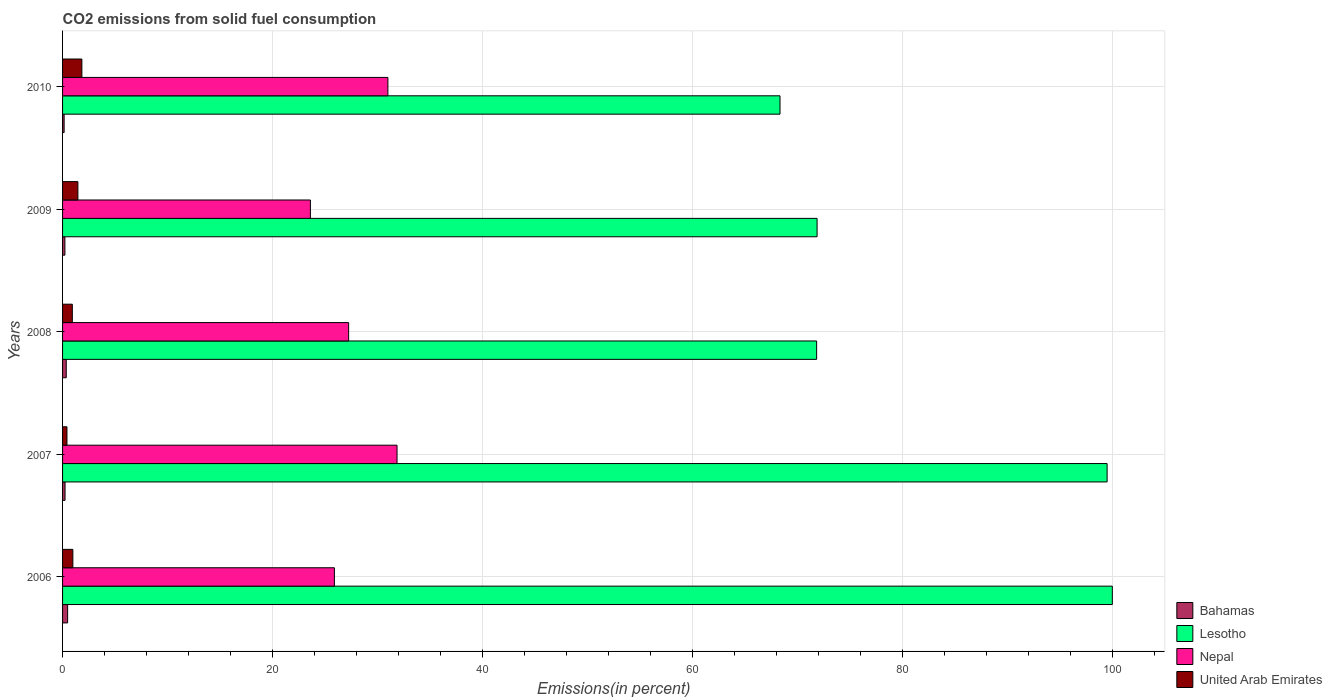How many bars are there on the 2nd tick from the bottom?
Offer a terse response. 4. What is the total CO2 emitted in Lesotho in 2009?
Your answer should be compact. 71.88. Across all years, what is the maximum total CO2 emitted in Nepal?
Provide a short and direct response. 31.86. Across all years, what is the minimum total CO2 emitted in Nepal?
Provide a short and direct response. 23.61. In which year was the total CO2 emitted in Lesotho maximum?
Your answer should be very brief. 2006. What is the total total CO2 emitted in Lesotho in the graph?
Your answer should be compact. 411.55. What is the difference between the total CO2 emitted in Nepal in 2007 and that in 2009?
Ensure brevity in your answer.  8.25. What is the difference between the total CO2 emitted in Nepal in 2009 and the total CO2 emitted in United Arab Emirates in 2008?
Offer a very short reply. 22.68. What is the average total CO2 emitted in United Arab Emirates per year?
Provide a succinct answer. 1.13. In the year 2009, what is the difference between the total CO2 emitted in United Arab Emirates and total CO2 emitted in Lesotho?
Make the answer very short. -70.42. In how many years, is the total CO2 emitted in United Arab Emirates greater than 84 %?
Make the answer very short. 0. What is the ratio of the total CO2 emitted in United Arab Emirates in 2007 to that in 2009?
Ensure brevity in your answer.  0.29. Is the total CO2 emitted in Lesotho in 2007 less than that in 2008?
Make the answer very short. No. Is the difference between the total CO2 emitted in United Arab Emirates in 2007 and 2009 greater than the difference between the total CO2 emitted in Lesotho in 2007 and 2009?
Your answer should be very brief. No. What is the difference between the highest and the second highest total CO2 emitted in United Arab Emirates?
Make the answer very short. 0.38. What is the difference between the highest and the lowest total CO2 emitted in Nepal?
Provide a short and direct response. 8.25. Is the sum of the total CO2 emitted in Nepal in 2006 and 2007 greater than the maximum total CO2 emitted in United Arab Emirates across all years?
Provide a short and direct response. Yes. Is it the case that in every year, the sum of the total CO2 emitted in Bahamas and total CO2 emitted in United Arab Emirates is greater than the sum of total CO2 emitted in Nepal and total CO2 emitted in Lesotho?
Offer a very short reply. No. What does the 1st bar from the top in 2006 represents?
Offer a terse response. United Arab Emirates. What does the 1st bar from the bottom in 2008 represents?
Your response must be concise. Bahamas. How many bars are there?
Provide a short and direct response. 20. Are all the bars in the graph horizontal?
Your response must be concise. Yes. How many years are there in the graph?
Provide a short and direct response. 5. What is the difference between two consecutive major ticks on the X-axis?
Provide a succinct answer. 20. Are the values on the major ticks of X-axis written in scientific E-notation?
Offer a very short reply. No. Does the graph contain grids?
Offer a terse response. Yes. How are the legend labels stacked?
Keep it short and to the point. Vertical. What is the title of the graph?
Give a very brief answer. CO2 emissions from solid fuel consumption. What is the label or title of the X-axis?
Your response must be concise. Emissions(in percent). What is the Emissions(in percent) of Bahamas in 2006?
Give a very brief answer. 0.48. What is the Emissions(in percent) in Nepal in 2006?
Your response must be concise. 25.9. What is the Emissions(in percent) in United Arab Emirates in 2006?
Provide a succinct answer. 0.98. What is the Emissions(in percent) in Bahamas in 2007?
Ensure brevity in your answer.  0.24. What is the Emissions(in percent) of Lesotho in 2007?
Offer a very short reply. 99.5. What is the Emissions(in percent) of Nepal in 2007?
Your response must be concise. 31.86. What is the Emissions(in percent) in United Arab Emirates in 2007?
Keep it short and to the point. 0.42. What is the Emissions(in percent) of Bahamas in 2008?
Your response must be concise. 0.35. What is the Emissions(in percent) in Lesotho in 2008?
Provide a succinct answer. 71.83. What is the Emissions(in percent) in Nepal in 2008?
Your answer should be compact. 27.25. What is the Emissions(in percent) of United Arab Emirates in 2008?
Your response must be concise. 0.93. What is the Emissions(in percent) of Bahamas in 2009?
Make the answer very short. 0.22. What is the Emissions(in percent) of Lesotho in 2009?
Offer a terse response. 71.88. What is the Emissions(in percent) in Nepal in 2009?
Provide a succinct answer. 23.61. What is the Emissions(in percent) in United Arab Emirates in 2009?
Your response must be concise. 1.46. What is the Emissions(in percent) in Bahamas in 2010?
Your answer should be very brief. 0.15. What is the Emissions(in percent) in Lesotho in 2010?
Your answer should be compact. 68.34. What is the Emissions(in percent) in Nepal in 2010?
Your answer should be compact. 30.99. What is the Emissions(in percent) in United Arab Emirates in 2010?
Ensure brevity in your answer.  1.84. Across all years, what is the maximum Emissions(in percent) of Bahamas?
Provide a succinct answer. 0.48. Across all years, what is the maximum Emissions(in percent) of Nepal?
Your answer should be very brief. 31.86. Across all years, what is the maximum Emissions(in percent) in United Arab Emirates?
Provide a short and direct response. 1.84. Across all years, what is the minimum Emissions(in percent) of Bahamas?
Your answer should be very brief. 0.15. Across all years, what is the minimum Emissions(in percent) of Lesotho?
Ensure brevity in your answer.  68.34. Across all years, what is the minimum Emissions(in percent) of Nepal?
Your response must be concise. 23.61. Across all years, what is the minimum Emissions(in percent) of United Arab Emirates?
Offer a terse response. 0.42. What is the total Emissions(in percent) in Bahamas in the graph?
Make the answer very short. 1.44. What is the total Emissions(in percent) of Lesotho in the graph?
Give a very brief answer. 411.55. What is the total Emissions(in percent) in Nepal in the graph?
Give a very brief answer. 139.6. What is the total Emissions(in percent) of United Arab Emirates in the graph?
Your response must be concise. 5.63. What is the difference between the Emissions(in percent) in Bahamas in 2006 and that in 2007?
Ensure brevity in your answer.  0.24. What is the difference between the Emissions(in percent) in Lesotho in 2006 and that in 2007?
Give a very brief answer. 0.5. What is the difference between the Emissions(in percent) of Nepal in 2006 and that in 2007?
Provide a short and direct response. -5.97. What is the difference between the Emissions(in percent) of United Arab Emirates in 2006 and that in 2007?
Ensure brevity in your answer.  0.56. What is the difference between the Emissions(in percent) in Bahamas in 2006 and that in 2008?
Your answer should be very brief. 0.13. What is the difference between the Emissions(in percent) of Lesotho in 2006 and that in 2008?
Your response must be concise. 28.17. What is the difference between the Emissions(in percent) of Nepal in 2006 and that in 2008?
Offer a terse response. -1.36. What is the difference between the Emissions(in percent) of United Arab Emirates in 2006 and that in 2008?
Offer a terse response. 0.05. What is the difference between the Emissions(in percent) in Bahamas in 2006 and that in 2009?
Provide a short and direct response. 0.26. What is the difference between the Emissions(in percent) in Lesotho in 2006 and that in 2009?
Offer a very short reply. 28.12. What is the difference between the Emissions(in percent) of Nepal in 2006 and that in 2009?
Provide a short and direct response. 2.29. What is the difference between the Emissions(in percent) in United Arab Emirates in 2006 and that in 2009?
Offer a very short reply. -0.48. What is the difference between the Emissions(in percent) in Bahamas in 2006 and that in 2010?
Offer a very short reply. 0.33. What is the difference between the Emissions(in percent) of Lesotho in 2006 and that in 2010?
Offer a very short reply. 31.66. What is the difference between the Emissions(in percent) in Nepal in 2006 and that in 2010?
Offer a terse response. -5.1. What is the difference between the Emissions(in percent) in United Arab Emirates in 2006 and that in 2010?
Provide a short and direct response. -0.86. What is the difference between the Emissions(in percent) in Bahamas in 2007 and that in 2008?
Offer a very short reply. -0.11. What is the difference between the Emissions(in percent) in Lesotho in 2007 and that in 2008?
Provide a succinct answer. 27.67. What is the difference between the Emissions(in percent) of Nepal in 2007 and that in 2008?
Your response must be concise. 4.61. What is the difference between the Emissions(in percent) of United Arab Emirates in 2007 and that in 2008?
Offer a very short reply. -0.51. What is the difference between the Emissions(in percent) of Bahamas in 2007 and that in 2009?
Ensure brevity in your answer.  0.01. What is the difference between the Emissions(in percent) in Lesotho in 2007 and that in 2009?
Ensure brevity in your answer.  27.63. What is the difference between the Emissions(in percent) of Nepal in 2007 and that in 2009?
Offer a terse response. 8.25. What is the difference between the Emissions(in percent) of United Arab Emirates in 2007 and that in 2009?
Keep it short and to the point. -1.04. What is the difference between the Emissions(in percent) of Bahamas in 2007 and that in 2010?
Provide a succinct answer. 0.09. What is the difference between the Emissions(in percent) of Lesotho in 2007 and that in 2010?
Your answer should be very brief. 31.16. What is the difference between the Emissions(in percent) of Nepal in 2007 and that in 2010?
Make the answer very short. 0.87. What is the difference between the Emissions(in percent) in United Arab Emirates in 2007 and that in 2010?
Make the answer very short. -1.42. What is the difference between the Emissions(in percent) in Bahamas in 2008 and that in 2009?
Your response must be concise. 0.13. What is the difference between the Emissions(in percent) of Lesotho in 2008 and that in 2009?
Your answer should be compact. -0.04. What is the difference between the Emissions(in percent) in Nepal in 2008 and that in 2009?
Give a very brief answer. 3.64. What is the difference between the Emissions(in percent) of United Arab Emirates in 2008 and that in 2009?
Provide a short and direct response. -0.53. What is the difference between the Emissions(in percent) of Bahamas in 2008 and that in 2010?
Your response must be concise. 0.2. What is the difference between the Emissions(in percent) of Lesotho in 2008 and that in 2010?
Your answer should be very brief. 3.49. What is the difference between the Emissions(in percent) of Nepal in 2008 and that in 2010?
Offer a terse response. -3.74. What is the difference between the Emissions(in percent) in United Arab Emirates in 2008 and that in 2010?
Offer a very short reply. -0.91. What is the difference between the Emissions(in percent) in Bahamas in 2009 and that in 2010?
Offer a terse response. 0.07. What is the difference between the Emissions(in percent) in Lesotho in 2009 and that in 2010?
Your answer should be very brief. 3.53. What is the difference between the Emissions(in percent) in Nepal in 2009 and that in 2010?
Offer a very short reply. -7.38. What is the difference between the Emissions(in percent) in United Arab Emirates in 2009 and that in 2010?
Offer a terse response. -0.38. What is the difference between the Emissions(in percent) in Bahamas in 2006 and the Emissions(in percent) in Lesotho in 2007?
Give a very brief answer. -99.02. What is the difference between the Emissions(in percent) in Bahamas in 2006 and the Emissions(in percent) in Nepal in 2007?
Keep it short and to the point. -31.38. What is the difference between the Emissions(in percent) of Bahamas in 2006 and the Emissions(in percent) of United Arab Emirates in 2007?
Give a very brief answer. 0.06. What is the difference between the Emissions(in percent) in Lesotho in 2006 and the Emissions(in percent) in Nepal in 2007?
Your response must be concise. 68.14. What is the difference between the Emissions(in percent) of Lesotho in 2006 and the Emissions(in percent) of United Arab Emirates in 2007?
Your answer should be very brief. 99.58. What is the difference between the Emissions(in percent) in Nepal in 2006 and the Emissions(in percent) in United Arab Emirates in 2007?
Provide a short and direct response. 25.48. What is the difference between the Emissions(in percent) of Bahamas in 2006 and the Emissions(in percent) of Lesotho in 2008?
Make the answer very short. -71.35. What is the difference between the Emissions(in percent) in Bahamas in 2006 and the Emissions(in percent) in Nepal in 2008?
Provide a short and direct response. -26.77. What is the difference between the Emissions(in percent) of Bahamas in 2006 and the Emissions(in percent) of United Arab Emirates in 2008?
Your answer should be very brief. -0.45. What is the difference between the Emissions(in percent) of Lesotho in 2006 and the Emissions(in percent) of Nepal in 2008?
Make the answer very short. 72.75. What is the difference between the Emissions(in percent) of Lesotho in 2006 and the Emissions(in percent) of United Arab Emirates in 2008?
Provide a succinct answer. 99.07. What is the difference between the Emissions(in percent) in Nepal in 2006 and the Emissions(in percent) in United Arab Emirates in 2008?
Offer a very short reply. 24.97. What is the difference between the Emissions(in percent) in Bahamas in 2006 and the Emissions(in percent) in Lesotho in 2009?
Make the answer very short. -71.39. What is the difference between the Emissions(in percent) in Bahamas in 2006 and the Emissions(in percent) in Nepal in 2009?
Keep it short and to the point. -23.12. What is the difference between the Emissions(in percent) of Bahamas in 2006 and the Emissions(in percent) of United Arab Emirates in 2009?
Your answer should be very brief. -0.98. What is the difference between the Emissions(in percent) of Lesotho in 2006 and the Emissions(in percent) of Nepal in 2009?
Ensure brevity in your answer.  76.39. What is the difference between the Emissions(in percent) in Lesotho in 2006 and the Emissions(in percent) in United Arab Emirates in 2009?
Offer a terse response. 98.54. What is the difference between the Emissions(in percent) in Nepal in 2006 and the Emissions(in percent) in United Arab Emirates in 2009?
Provide a short and direct response. 24.44. What is the difference between the Emissions(in percent) in Bahamas in 2006 and the Emissions(in percent) in Lesotho in 2010?
Provide a succinct answer. -67.86. What is the difference between the Emissions(in percent) of Bahamas in 2006 and the Emissions(in percent) of Nepal in 2010?
Offer a terse response. -30.51. What is the difference between the Emissions(in percent) in Bahamas in 2006 and the Emissions(in percent) in United Arab Emirates in 2010?
Offer a very short reply. -1.36. What is the difference between the Emissions(in percent) in Lesotho in 2006 and the Emissions(in percent) in Nepal in 2010?
Offer a terse response. 69.01. What is the difference between the Emissions(in percent) in Lesotho in 2006 and the Emissions(in percent) in United Arab Emirates in 2010?
Your answer should be very brief. 98.16. What is the difference between the Emissions(in percent) of Nepal in 2006 and the Emissions(in percent) of United Arab Emirates in 2010?
Your answer should be compact. 24.06. What is the difference between the Emissions(in percent) in Bahamas in 2007 and the Emissions(in percent) in Lesotho in 2008?
Keep it short and to the point. -71.59. What is the difference between the Emissions(in percent) in Bahamas in 2007 and the Emissions(in percent) in Nepal in 2008?
Keep it short and to the point. -27.01. What is the difference between the Emissions(in percent) in Bahamas in 2007 and the Emissions(in percent) in United Arab Emirates in 2008?
Offer a very short reply. -0.69. What is the difference between the Emissions(in percent) in Lesotho in 2007 and the Emissions(in percent) in Nepal in 2008?
Your answer should be compact. 72.25. What is the difference between the Emissions(in percent) of Lesotho in 2007 and the Emissions(in percent) of United Arab Emirates in 2008?
Offer a terse response. 98.57. What is the difference between the Emissions(in percent) of Nepal in 2007 and the Emissions(in percent) of United Arab Emirates in 2008?
Offer a terse response. 30.93. What is the difference between the Emissions(in percent) in Bahamas in 2007 and the Emissions(in percent) in Lesotho in 2009?
Your answer should be compact. -71.64. What is the difference between the Emissions(in percent) of Bahamas in 2007 and the Emissions(in percent) of Nepal in 2009?
Give a very brief answer. -23.37. What is the difference between the Emissions(in percent) of Bahamas in 2007 and the Emissions(in percent) of United Arab Emirates in 2009?
Your answer should be very brief. -1.22. What is the difference between the Emissions(in percent) of Lesotho in 2007 and the Emissions(in percent) of Nepal in 2009?
Provide a short and direct response. 75.9. What is the difference between the Emissions(in percent) of Lesotho in 2007 and the Emissions(in percent) of United Arab Emirates in 2009?
Your response must be concise. 98.04. What is the difference between the Emissions(in percent) of Nepal in 2007 and the Emissions(in percent) of United Arab Emirates in 2009?
Your answer should be compact. 30.4. What is the difference between the Emissions(in percent) of Bahamas in 2007 and the Emissions(in percent) of Lesotho in 2010?
Your answer should be compact. -68.11. What is the difference between the Emissions(in percent) of Bahamas in 2007 and the Emissions(in percent) of Nepal in 2010?
Your answer should be compact. -30.75. What is the difference between the Emissions(in percent) of Bahamas in 2007 and the Emissions(in percent) of United Arab Emirates in 2010?
Offer a terse response. -1.6. What is the difference between the Emissions(in percent) of Lesotho in 2007 and the Emissions(in percent) of Nepal in 2010?
Keep it short and to the point. 68.51. What is the difference between the Emissions(in percent) of Lesotho in 2007 and the Emissions(in percent) of United Arab Emirates in 2010?
Make the answer very short. 97.66. What is the difference between the Emissions(in percent) in Nepal in 2007 and the Emissions(in percent) in United Arab Emirates in 2010?
Your answer should be very brief. 30.02. What is the difference between the Emissions(in percent) of Bahamas in 2008 and the Emissions(in percent) of Lesotho in 2009?
Your answer should be very brief. -71.52. What is the difference between the Emissions(in percent) in Bahamas in 2008 and the Emissions(in percent) in Nepal in 2009?
Offer a very short reply. -23.26. What is the difference between the Emissions(in percent) in Bahamas in 2008 and the Emissions(in percent) in United Arab Emirates in 2009?
Ensure brevity in your answer.  -1.11. What is the difference between the Emissions(in percent) in Lesotho in 2008 and the Emissions(in percent) in Nepal in 2009?
Offer a terse response. 48.22. What is the difference between the Emissions(in percent) in Lesotho in 2008 and the Emissions(in percent) in United Arab Emirates in 2009?
Ensure brevity in your answer.  70.37. What is the difference between the Emissions(in percent) in Nepal in 2008 and the Emissions(in percent) in United Arab Emirates in 2009?
Offer a very short reply. 25.79. What is the difference between the Emissions(in percent) of Bahamas in 2008 and the Emissions(in percent) of Lesotho in 2010?
Provide a short and direct response. -67.99. What is the difference between the Emissions(in percent) of Bahamas in 2008 and the Emissions(in percent) of Nepal in 2010?
Offer a terse response. -30.64. What is the difference between the Emissions(in percent) of Bahamas in 2008 and the Emissions(in percent) of United Arab Emirates in 2010?
Offer a terse response. -1.49. What is the difference between the Emissions(in percent) in Lesotho in 2008 and the Emissions(in percent) in Nepal in 2010?
Your answer should be compact. 40.84. What is the difference between the Emissions(in percent) of Lesotho in 2008 and the Emissions(in percent) of United Arab Emirates in 2010?
Provide a short and direct response. 69.99. What is the difference between the Emissions(in percent) of Nepal in 2008 and the Emissions(in percent) of United Arab Emirates in 2010?
Keep it short and to the point. 25.41. What is the difference between the Emissions(in percent) of Bahamas in 2009 and the Emissions(in percent) of Lesotho in 2010?
Make the answer very short. -68.12. What is the difference between the Emissions(in percent) of Bahamas in 2009 and the Emissions(in percent) of Nepal in 2010?
Keep it short and to the point. -30.77. What is the difference between the Emissions(in percent) of Bahamas in 2009 and the Emissions(in percent) of United Arab Emirates in 2010?
Offer a terse response. -1.62. What is the difference between the Emissions(in percent) of Lesotho in 2009 and the Emissions(in percent) of Nepal in 2010?
Provide a succinct answer. 40.88. What is the difference between the Emissions(in percent) in Lesotho in 2009 and the Emissions(in percent) in United Arab Emirates in 2010?
Your answer should be very brief. 70.03. What is the difference between the Emissions(in percent) of Nepal in 2009 and the Emissions(in percent) of United Arab Emirates in 2010?
Your answer should be compact. 21.77. What is the average Emissions(in percent) of Bahamas per year?
Ensure brevity in your answer.  0.29. What is the average Emissions(in percent) in Lesotho per year?
Ensure brevity in your answer.  82.31. What is the average Emissions(in percent) in Nepal per year?
Offer a very short reply. 27.92. What is the average Emissions(in percent) of United Arab Emirates per year?
Provide a succinct answer. 1.13. In the year 2006, what is the difference between the Emissions(in percent) in Bahamas and Emissions(in percent) in Lesotho?
Ensure brevity in your answer.  -99.52. In the year 2006, what is the difference between the Emissions(in percent) in Bahamas and Emissions(in percent) in Nepal?
Offer a very short reply. -25.41. In the year 2006, what is the difference between the Emissions(in percent) of Bahamas and Emissions(in percent) of United Arab Emirates?
Your answer should be very brief. -0.5. In the year 2006, what is the difference between the Emissions(in percent) of Lesotho and Emissions(in percent) of Nepal?
Offer a very short reply. 74.1. In the year 2006, what is the difference between the Emissions(in percent) in Lesotho and Emissions(in percent) in United Arab Emirates?
Keep it short and to the point. 99.02. In the year 2006, what is the difference between the Emissions(in percent) in Nepal and Emissions(in percent) in United Arab Emirates?
Ensure brevity in your answer.  24.92. In the year 2007, what is the difference between the Emissions(in percent) of Bahamas and Emissions(in percent) of Lesotho?
Give a very brief answer. -99.27. In the year 2007, what is the difference between the Emissions(in percent) in Bahamas and Emissions(in percent) in Nepal?
Your answer should be compact. -31.62. In the year 2007, what is the difference between the Emissions(in percent) in Bahamas and Emissions(in percent) in United Arab Emirates?
Offer a terse response. -0.18. In the year 2007, what is the difference between the Emissions(in percent) of Lesotho and Emissions(in percent) of Nepal?
Your response must be concise. 67.64. In the year 2007, what is the difference between the Emissions(in percent) of Lesotho and Emissions(in percent) of United Arab Emirates?
Provide a succinct answer. 99.08. In the year 2007, what is the difference between the Emissions(in percent) of Nepal and Emissions(in percent) of United Arab Emirates?
Your answer should be very brief. 31.44. In the year 2008, what is the difference between the Emissions(in percent) of Bahamas and Emissions(in percent) of Lesotho?
Provide a short and direct response. -71.48. In the year 2008, what is the difference between the Emissions(in percent) in Bahamas and Emissions(in percent) in Nepal?
Your answer should be compact. -26.9. In the year 2008, what is the difference between the Emissions(in percent) of Bahamas and Emissions(in percent) of United Arab Emirates?
Offer a very short reply. -0.58. In the year 2008, what is the difference between the Emissions(in percent) of Lesotho and Emissions(in percent) of Nepal?
Make the answer very short. 44.58. In the year 2008, what is the difference between the Emissions(in percent) of Lesotho and Emissions(in percent) of United Arab Emirates?
Give a very brief answer. 70.9. In the year 2008, what is the difference between the Emissions(in percent) of Nepal and Emissions(in percent) of United Arab Emirates?
Offer a very short reply. 26.32. In the year 2009, what is the difference between the Emissions(in percent) in Bahamas and Emissions(in percent) in Lesotho?
Give a very brief answer. -71.65. In the year 2009, what is the difference between the Emissions(in percent) of Bahamas and Emissions(in percent) of Nepal?
Keep it short and to the point. -23.38. In the year 2009, what is the difference between the Emissions(in percent) of Bahamas and Emissions(in percent) of United Arab Emirates?
Provide a succinct answer. -1.24. In the year 2009, what is the difference between the Emissions(in percent) in Lesotho and Emissions(in percent) in Nepal?
Provide a short and direct response. 48.27. In the year 2009, what is the difference between the Emissions(in percent) in Lesotho and Emissions(in percent) in United Arab Emirates?
Ensure brevity in your answer.  70.42. In the year 2009, what is the difference between the Emissions(in percent) of Nepal and Emissions(in percent) of United Arab Emirates?
Offer a terse response. 22.15. In the year 2010, what is the difference between the Emissions(in percent) of Bahamas and Emissions(in percent) of Lesotho?
Keep it short and to the point. -68.2. In the year 2010, what is the difference between the Emissions(in percent) in Bahamas and Emissions(in percent) in Nepal?
Your answer should be compact. -30.84. In the year 2010, what is the difference between the Emissions(in percent) in Bahamas and Emissions(in percent) in United Arab Emirates?
Provide a short and direct response. -1.69. In the year 2010, what is the difference between the Emissions(in percent) in Lesotho and Emissions(in percent) in Nepal?
Offer a very short reply. 37.35. In the year 2010, what is the difference between the Emissions(in percent) in Lesotho and Emissions(in percent) in United Arab Emirates?
Provide a short and direct response. 66.5. In the year 2010, what is the difference between the Emissions(in percent) in Nepal and Emissions(in percent) in United Arab Emirates?
Keep it short and to the point. 29.15. What is the ratio of the Emissions(in percent) in Bahamas in 2006 to that in 2007?
Provide a succinct answer. 2.03. What is the ratio of the Emissions(in percent) in Nepal in 2006 to that in 2007?
Keep it short and to the point. 0.81. What is the ratio of the Emissions(in percent) of United Arab Emirates in 2006 to that in 2007?
Keep it short and to the point. 2.34. What is the ratio of the Emissions(in percent) in Bahamas in 2006 to that in 2008?
Offer a very short reply. 1.37. What is the ratio of the Emissions(in percent) of Lesotho in 2006 to that in 2008?
Your answer should be compact. 1.39. What is the ratio of the Emissions(in percent) of Nepal in 2006 to that in 2008?
Your response must be concise. 0.95. What is the ratio of the Emissions(in percent) in United Arab Emirates in 2006 to that in 2008?
Offer a very short reply. 1.05. What is the ratio of the Emissions(in percent) in Bahamas in 2006 to that in 2009?
Ensure brevity in your answer.  2.16. What is the ratio of the Emissions(in percent) in Lesotho in 2006 to that in 2009?
Offer a very short reply. 1.39. What is the ratio of the Emissions(in percent) in Nepal in 2006 to that in 2009?
Provide a succinct answer. 1.1. What is the ratio of the Emissions(in percent) in United Arab Emirates in 2006 to that in 2009?
Give a very brief answer. 0.67. What is the ratio of the Emissions(in percent) of Bahamas in 2006 to that in 2010?
Provide a succinct answer. 3.24. What is the ratio of the Emissions(in percent) of Lesotho in 2006 to that in 2010?
Provide a short and direct response. 1.46. What is the ratio of the Emissions(in percent) of Nepal in 2006 to that in 2010?
Provide a short and direct response. 0.84. What is the ratio of the Emissions(in percent) in United Arab Emirates in 2006 to that in 2010?
Provide a succinct answer. 0.53. What is the ratio of the Emissions(in percent) of Bahamas in 2007 to that in 2008?
Ensure brevity in your answer.  0.68. What is the ratio of the Emissions(in percent) of Lesotho in 2007 to that in 2008?
Ensure brevity in your answer.  1.39. What is the ratio of the Emissions(in percent) of Nepal in 2007 to that in 2008?
Keep it short and to the point. 1.17. What is the ratio of the Emissions(in percent) of United Arab Emirates in 2007 to that in 2008?
Ensure brevity in your answer.  0.45. What is the ratio of the Emissions(in percent) of Bahamas in 2007 to that in 2009?
Offer a terse response. 1.06. What is the ratio of the Emissions(in percent) of Lesotho in 2007 to that in 2009?
Provide a short and direct response. 1.38. What is the ratio of the Emissions(in percent) in Nepal in 2007 to that in 2009?
Offer a very short reply. 1.35. What is the ratio of the Emissions(in percent) of United Arab Emirates in 2007 to that in 2009?
Your answer should be very brief. 0.29. What is the ratio of the Emissions(in percent) in Bahamas in 2007 to that in 2010?
Offer a terse response. 1.59. What is the ratio of the Emissions(in percent) of Lesotho in 2007 to that in 2010?
Provide a succinct answer. 1.46. What is the ratio of the Emissions(in percent) in Nepal in 2007 to that in 2010?
Provide a succinct answer. 1.03. What is the ratio of the Emissions(in percent) in United Arab Emirates in 2007 to that in 2010?
Your answer should be very brief. 0.23. What is the ratio of the Emissions(in percent) in Bahamas in 2008 to that in 2009?
Give a very brief answer. 1.57. What is the ratio of the Emissions(in percent) of Nepal in 2008 to that in 2009?
Give a very brief answer. 1.15. What is the ratio of the Emissions(in percent) in United Arab Emirates in 2008 to that in 2009?
Ensure brevity in your answer.  0.64. What is the ratio of the Emissions(in percent) of Bahamas in 2008 to that in 2010?
Your response must be concise. 2.36. What is the ratio of the Emissions(in percent) of Lesotho in 2008 to that in 2010?
Ensure brevity in your answer.  1.05. What is the ratio of the Emissions(in percent) in Nepal in 2008 to that in 2010?
Your answer should be very brief. 0.88. What is the ratio of the Emissions(in percent) in United Arab Emirates in 2008 to that in 2010?
Provide a short and direct response. 0.51. What is the ratio of the Emissions(in percent) in Bahamas in 2009 to that in 2010?
Keep it short and to the point. 1.5. What is the ratio of the Emissions(in percent) in Lesotho in 2009 to that in 2010?
Keep it short and to the point. 1.05. What is the ratio of the Emissions(in percent) of Nepal in 2009 to that in 2010?
Keep it short and to the point. 0.76. What is the ratio of the Emissions(in percent) of United Arab Emirates in 2009 to that in 2010?
Ensure brevity in your answer.  0.79. What is the difference between the highest and the second highest Emissions(in percent) of Bahamas?
Offer a terse response. 0.13. What is the difference between the highest and the second highest Emissions(in percent) of Lesotho?
Your response must be concise. 0.5. What is the difference between the highest and the second highest Emissions(in percent) of Nepal?
Make the answer very short. 0.87. What is the difference between the highest and the second highest Emissions(in percent) of United Arab Emirates?
Offer a very short reply. 0.38. What is the difference between the highest and the lowest Emissions(in percent) in Bahamas?
Ensure brevity in your answer.  0.33. What is the difference between the highest and the lowest Emissions(in percent) in Lesotho?
Your answer should be very brief. 31.66. What is the difference between the highest and the lowest Emissions(in percent) in Nepal?
Ensure brevity in your answer.  8.25. What is the difference between the highest and the lowest Emissions(in percent) of United Arab Emirates?
Ensure brevity in your answer.  1.42. 